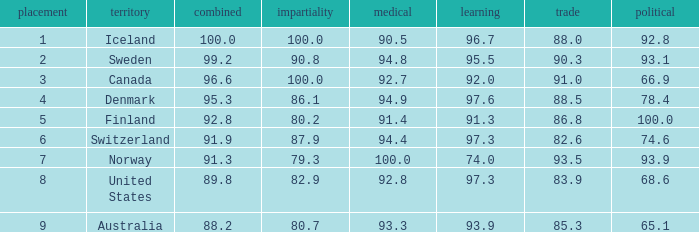What's the health score with justice being 80.7 93.3. 